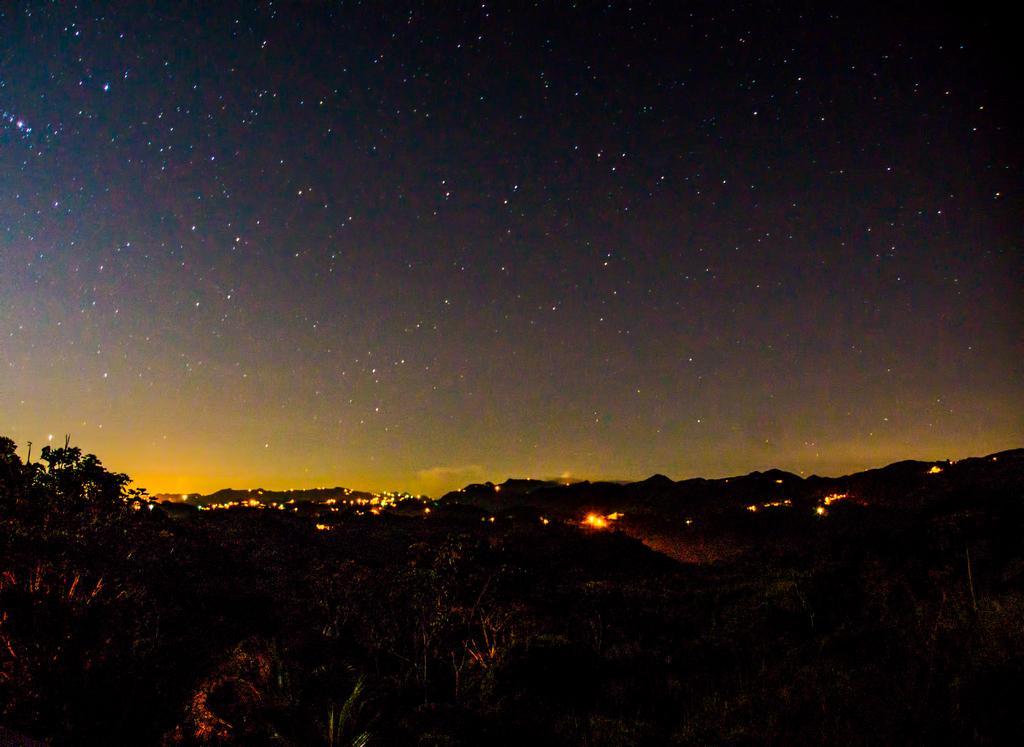Please provide a concise description of this image. In this picture we can see trees and lights. In the background of the image we can see the sky. 